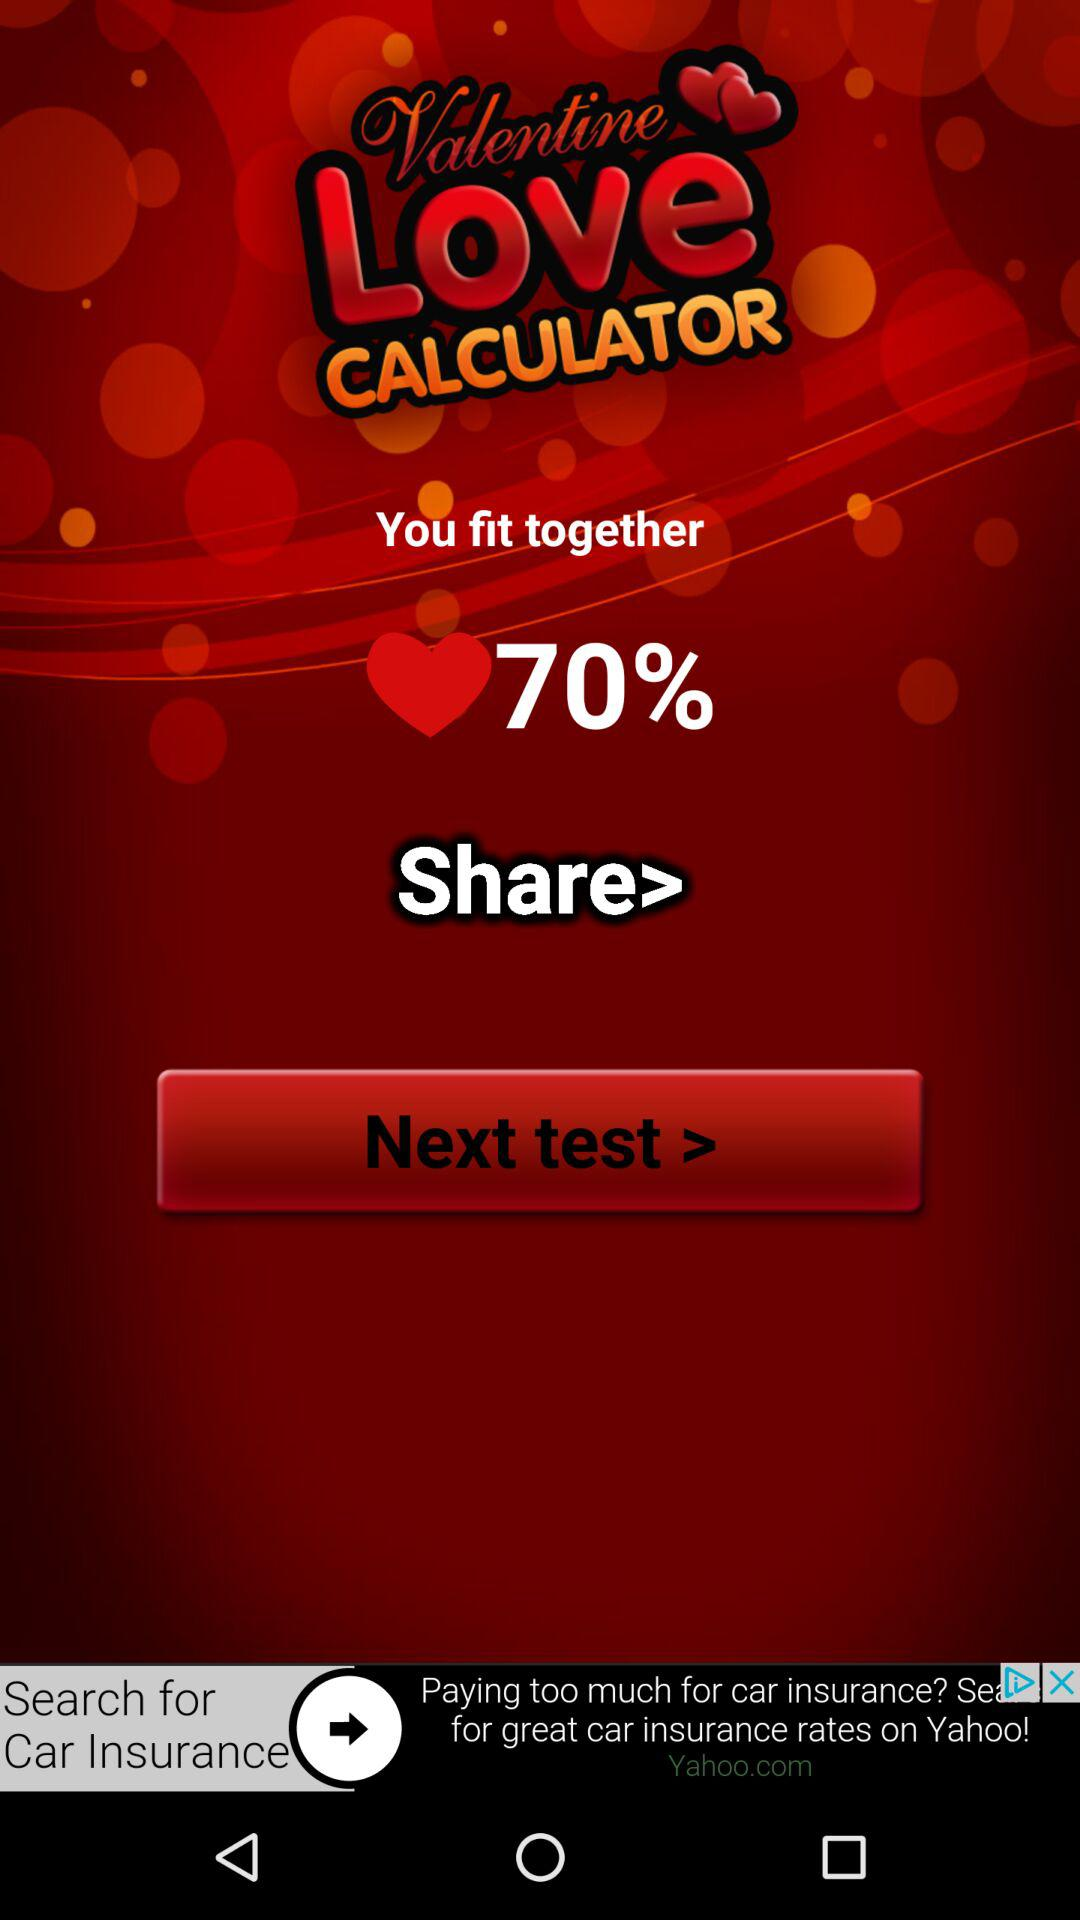What is the application name? The application name is "Valentine Love CALCULATOR". 